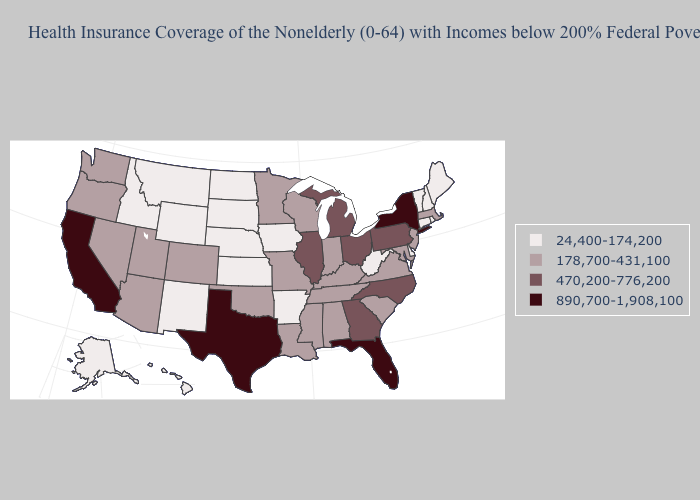What is the value of Vermont?
Write a very short answer. 24,400-174,200. Does Florida have the highest value in the USA?
Concise answer only. Yes. What is the highest value in the Northeast ?
Be succinct. 890,700-1,908,100. Name the states that have a value in the range 178,700-431,100?
Quick response, please. Alabama, Arizona, Colorado, Indiana, Kentucky, Louisiana, Maryland, Massachusetts, Minnesota, Mississippi, Missouri, Nevada, New Jersey, Oklahoma, Oregon, South Carolina, Tennessee, Utah, Virginia, Washington, Wisconsin. Does Iowa have the highest value in the MidWest?
Write a very short answer. No. Does Hawaii have the lowest value in the USA?
Answer briefly. Yes. Does the first symbol in the legend represent the smallest category?
Be succinct. Yes. Name the states that have a value in the range 24,400-174,200?
Concise answer only. Alaska, Arkansas, Connecticut, Delaware, Hawaii, Idaho, Iowa, Kansas, Maine, Montana, Nebraska, New Hampshire, New Mexico, North Dakota, Rhode Island, South Dakota, Vermont, West Virginia, Wyoming. Name the states that have a value in the range 890,700-1,908,100?
Concise answer only. California, Florida, New York, Texas. How many symbols are there in the legend?
Give a very brief answer. 4. Does Hawaii have the same value as Vermont?
Be succinct. Yes. What is the value of Nebraska?
Answer briefly. 24,400-174,200. What is the lowest value in the West?
Concise answer only. 24,400-174,200. Is the legend a continuous bar?
Keep it brief. No. Does Kentucky have the same value as Minnesota?
Write a very short answer. Yes. 